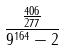<formula> <loc_0><loc_0><loc_500><loc_500>\frac { \frac { 4 0 6 } { 2 7 7 } } { 9 ^ { 1 6 4 } - 2 }</formula> 